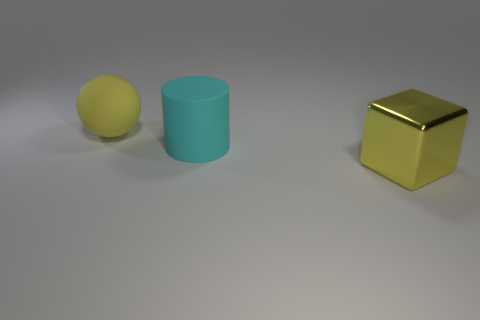What materials do the objects in the image seem to be made of? The objects in the image appear to be made of different materials. Starting from the left, the sphere seems to have a matte finish, possibly a plastic or rubber material. The cylinder in the center looks like it could be a ceramic or frosted glass due to its translucent appearance. Finally, the cube on the right has a reflective surface, which suggests it could be a metallic material, like polished gold or brass. 